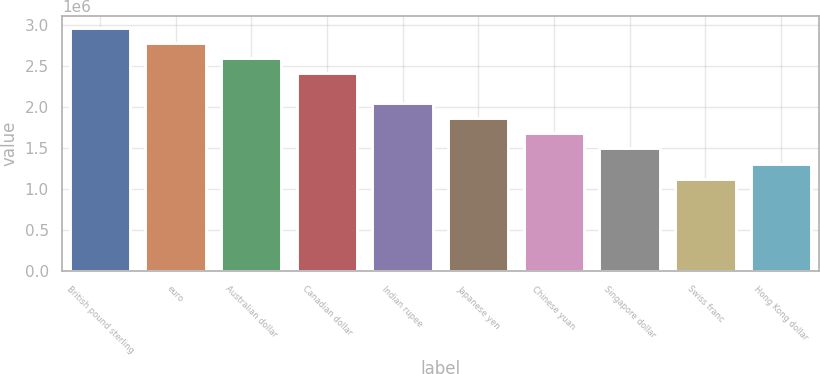Convert chart to OTSL. <chart><loc_0><loc_0><loc_500><loc_500><bar_chart><fcel>British pound sterling<fcel>euro<fcel>Australian dollar<fcel>Canadian dollar<fcel>Indian rupee<fcel>Japanese yen<fcel>Chinese yuan<fcel>Singapore dollar<fcel>Swiss franc<fcel>Hong Kong dollar<nl><fcel>2.96251e+06<fcel>2.77896e+06<fcel>2.59541e+06<fcel>2.41186e+06<fcel>2.04475e+06<fcel>1.8612e+06<fcel>1.67765e+06<fcel>1.49409e+06<fcel>1.12699e+06<fcel>1.31054e+06<nl></chart> 